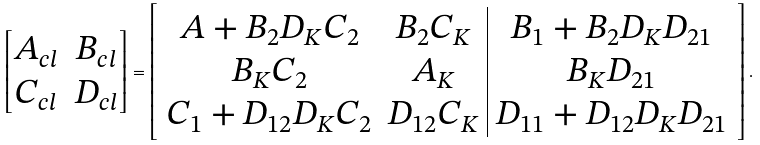Convert formula to latex. <formula><loc_0><loc_0><loc_500><loc_500>\begin{bmatrix} A _ { c l } & B _ { c l } \\ C _ { c l } & D _ { c l } \end{bmatrix} = \left [ \begin{array} { c c | c } A + B _ { 2 } D _ { K } C _ { 2 } & B _ { 2 } C _ { K } & B _ { 1 } + B _ { 2 } D _ { K } D _ { 2 1 } \\ B _ { K } C _ { 2 } & A _ { K } & B _ { K } D _ { 2 1 } \\ C _ { 1 } + D _ { 1 2 } D _ { K } C _ { 2 } & D _ { 1 2 } C _ { K } & D _ { 1 1 } + D _ { 1 2 } D _ { K } D _ { 2 1 } \end{array} \right ] .</formula> 